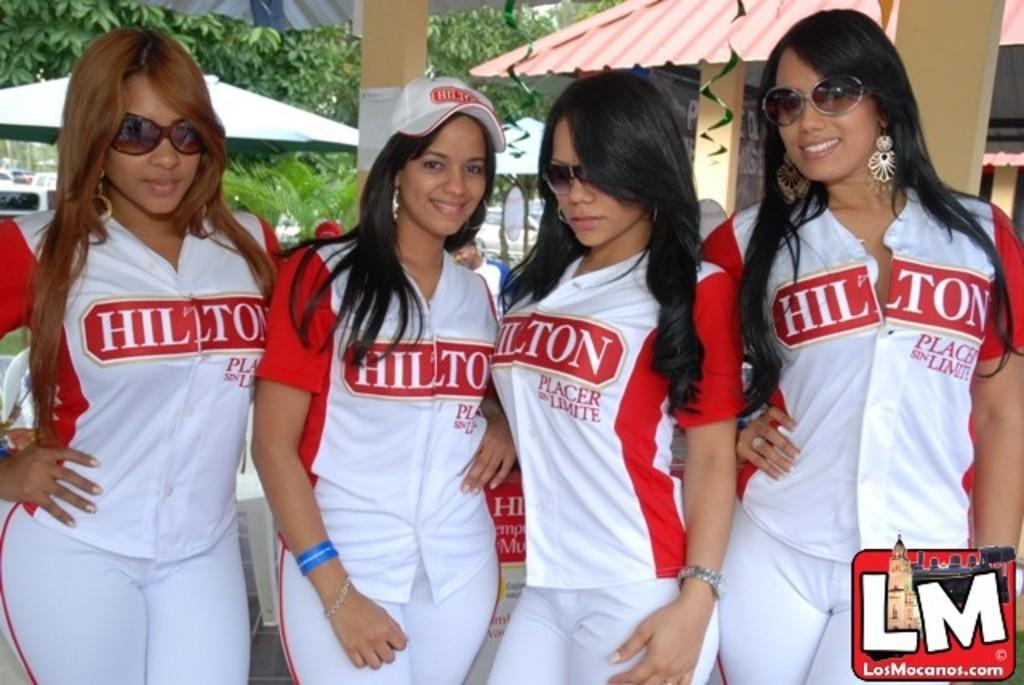How would you summarize this image in a sentence or two? In this image there are four women standing and one woman is wearing a cap, and three of them are wearing goggles. And in the background there are houses, trees and pillars and objects. And in the bottom right hand corner there is a logo and also we would see a chair and board. 